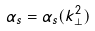Convert formula to latex. <formula><loc_0><loc_0><loc_500><loc_500>\alpha _ { s } = \alpha _ { s } ( k ^ { 2 } _ { \perp } )</formula> 